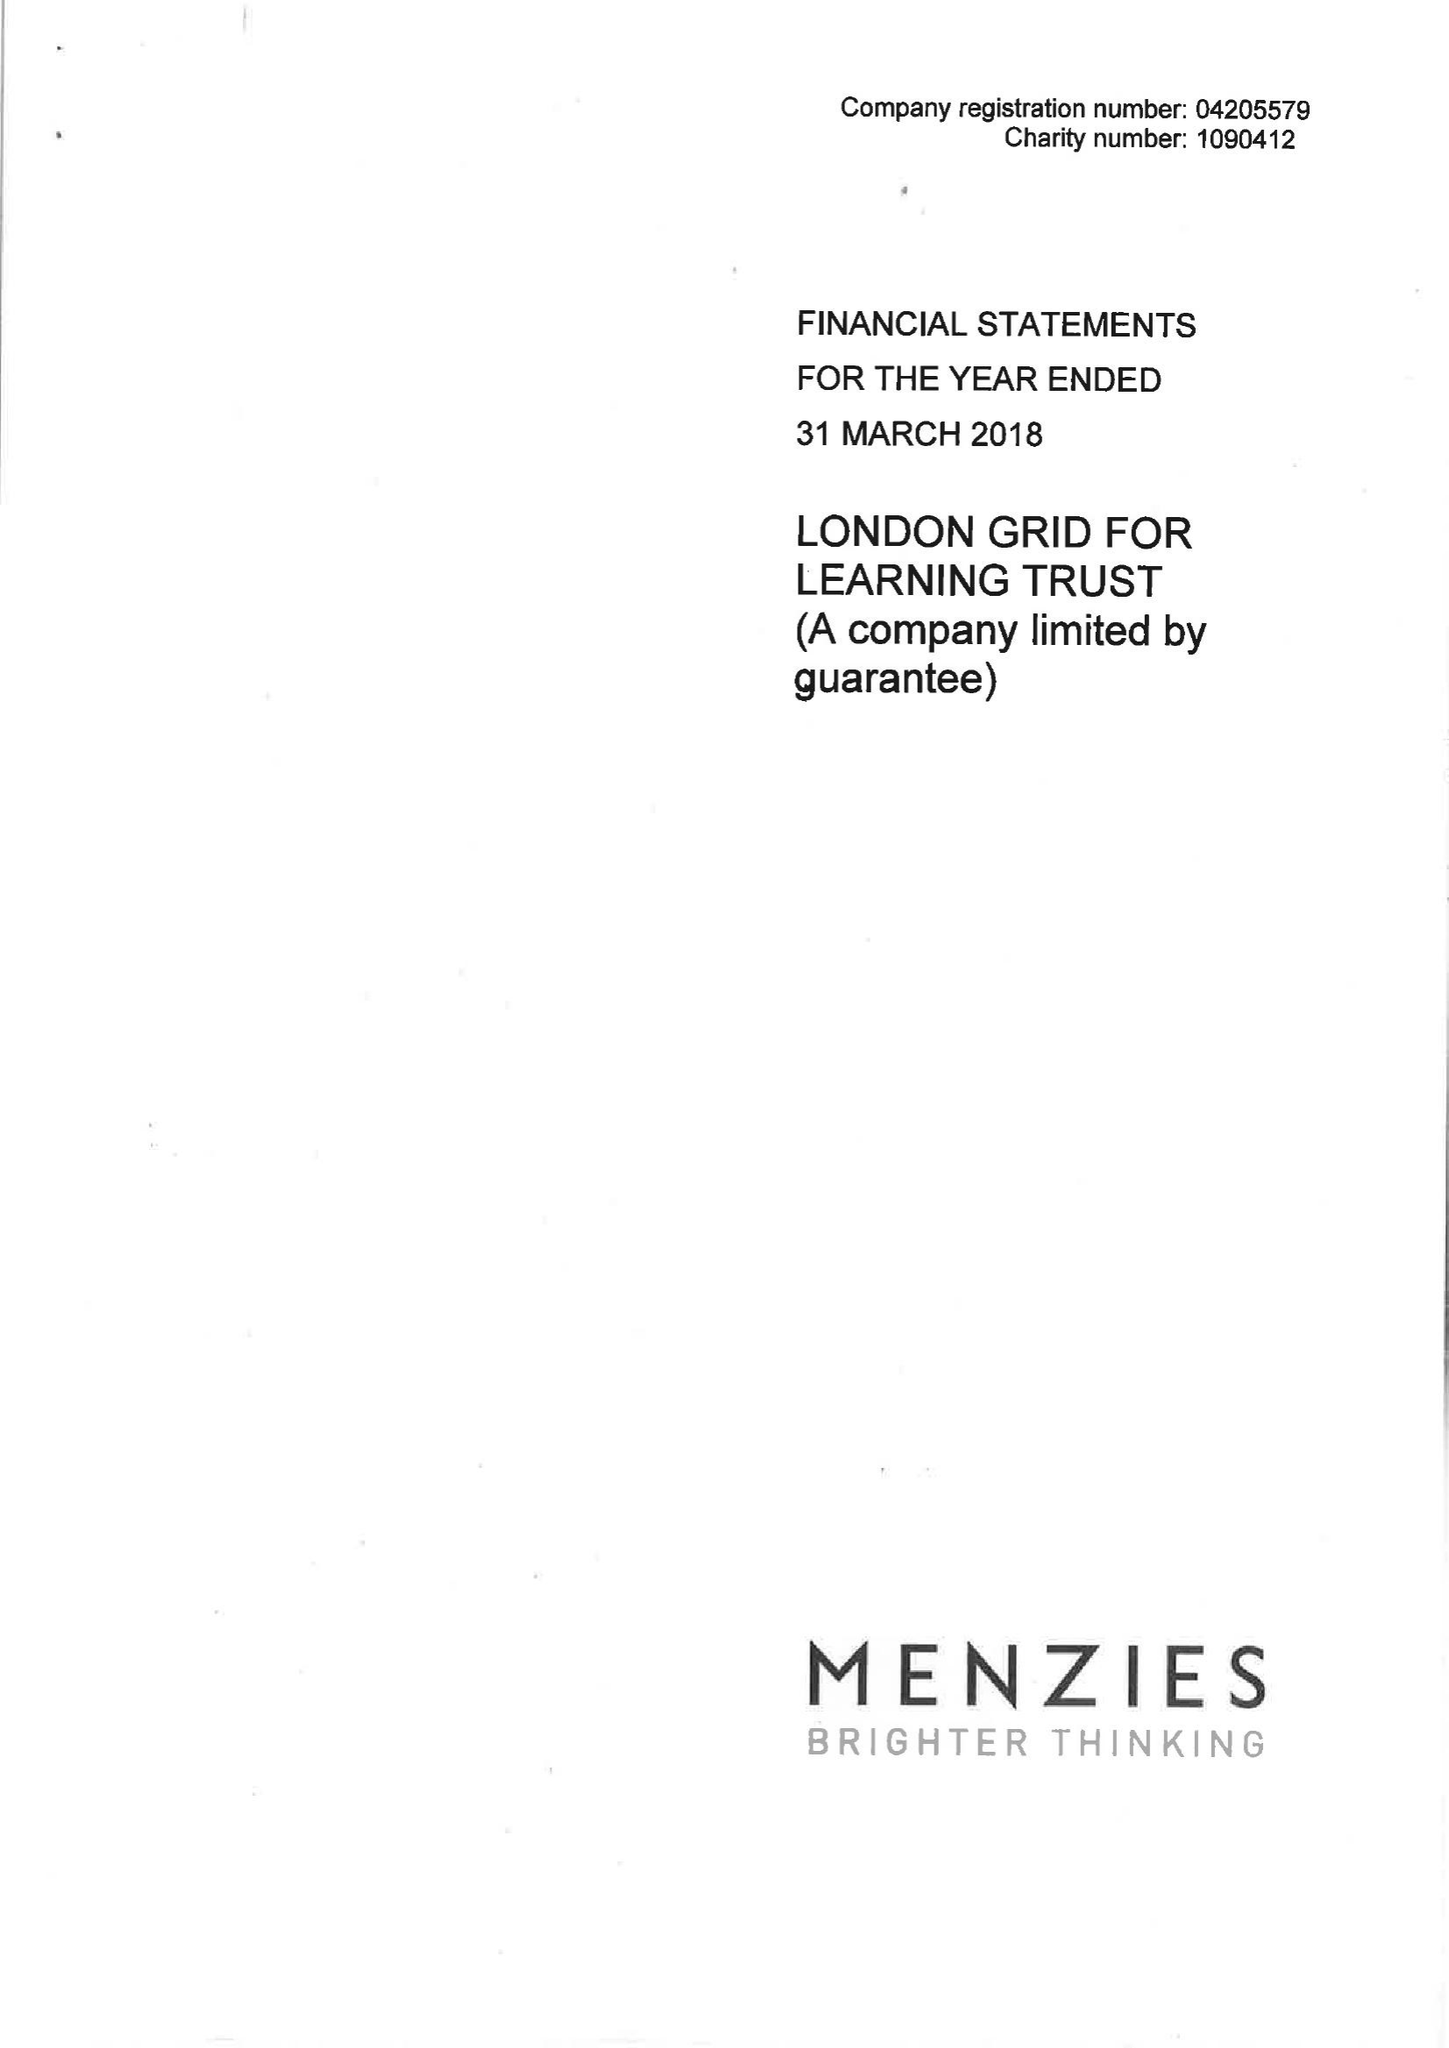What is the value for the address__postcode?
Answer the question using a single word or phrase. EC2A 2BR 